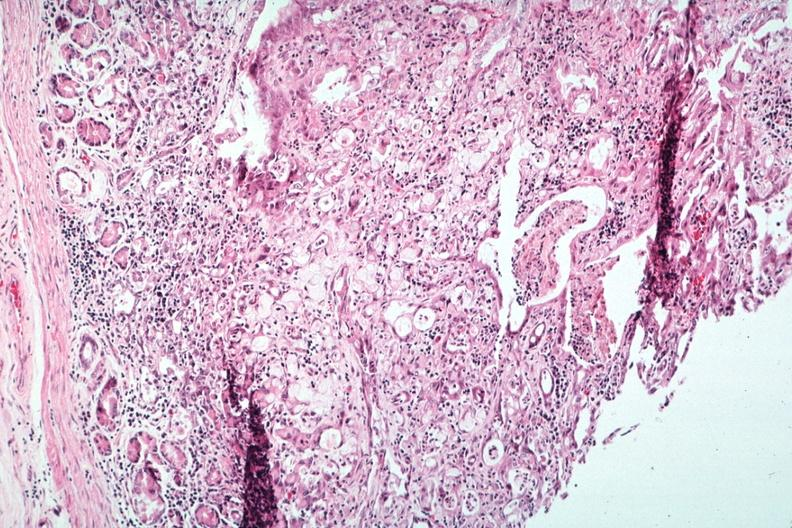what is present?
Answer the question using a single word or phrase. Metastatic carcinoma 